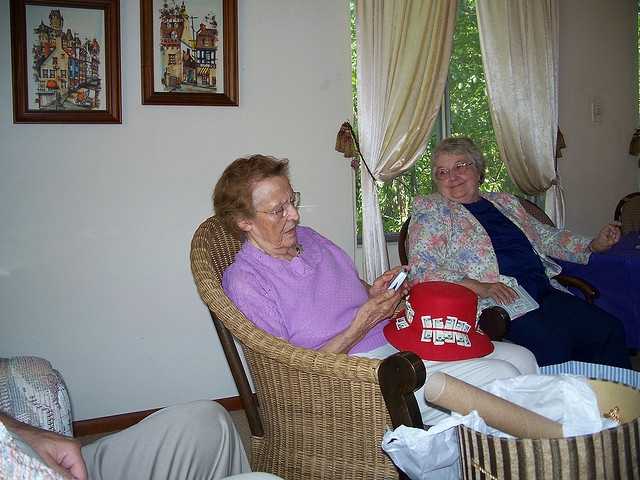Describe the objects in this image and their specific colors. I can see people in purple, black, gray, and darkgray tones, people in purple, violet, gray, and darkgray tones, chair in purple, gray, and tan tones, people in purple, darkgray, and gray tones, and chair in purple, darkgray, and gray tones in this image. 